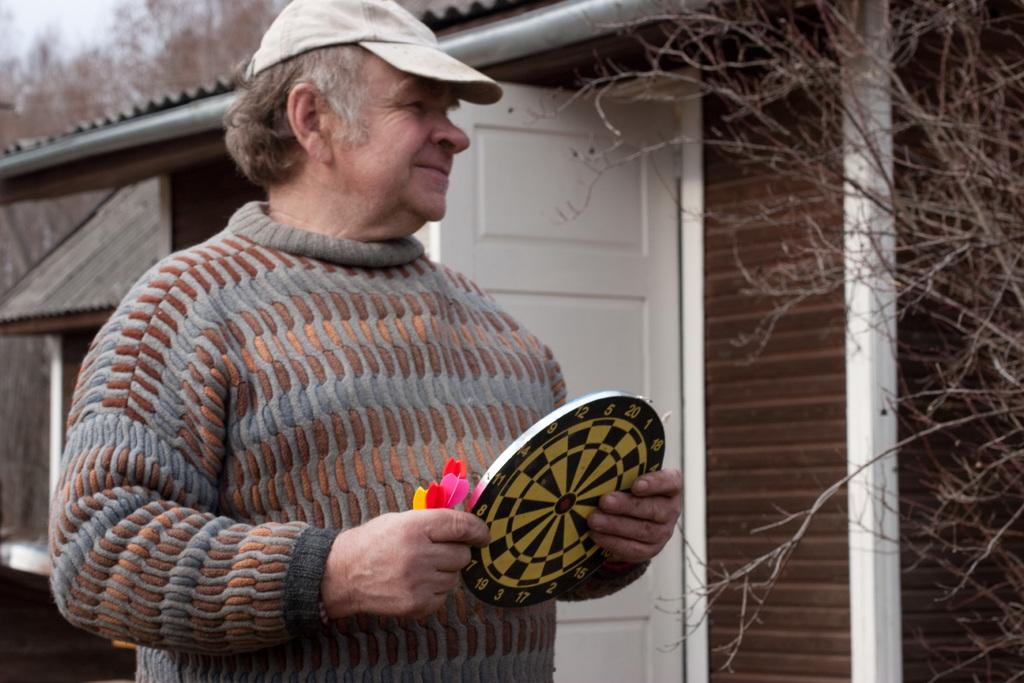Who is present in the image? There is a man in the image. Where is the man located in the image? The man is standing on the left side of the image. What can be seen in the background of the image? There is a house in the background of the image. What type of sticks are being used to stir the milk in the image? There is no milk or sticks present in the image. Where is the crib located in the image? There is no crib present in the image. 